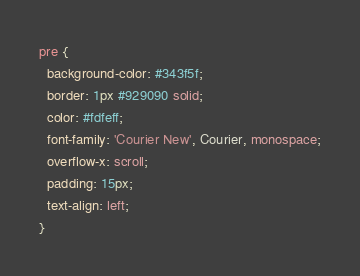<code> <loc_0><loc_0><loc_500><loc_500><_CSS_>pre {
  background-color: #343f5f;
  border: 1px #929090 solid;
  color: #fdfeff;
  font-family: 'Courier New', Courier, monospace;
  overflow-x: scroll;
  padding: 15px;
  text-align: left;
}
</code> 